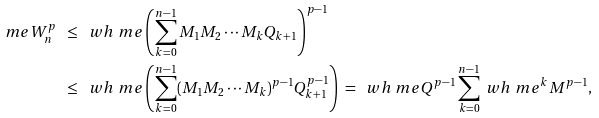Convert formula to latex. <formula><loc_0><loc_0><loc_500><loc_500>\ m e W _ { n } ^ { p } \ & \leq \ \ w h \ m e \left ( \sum _ { k = 0 } ^ { n - 1 } M _ { 1 } M _ { 2 } \cdots M _ { k } Q _ { k + 1 } \right ) ^ { p - 1 } \\ & \leq \ \ w h \ m e \left ( \sum _ { k = 0 } ^ { n - 1 } ( M _ { 1 } M _ { 2 } \cdots M _ { k } ) ^ { p - 1 } Q _ { k + 1 } ^ { p - 1 } \right ) \ = \ \ w h \ m e Q ^ { p - 1 } \sum _ { k = 0 } ^ { n - 1 } \ w h \ m e ^ { k } M ^ { p - 1 } ,</formula> 